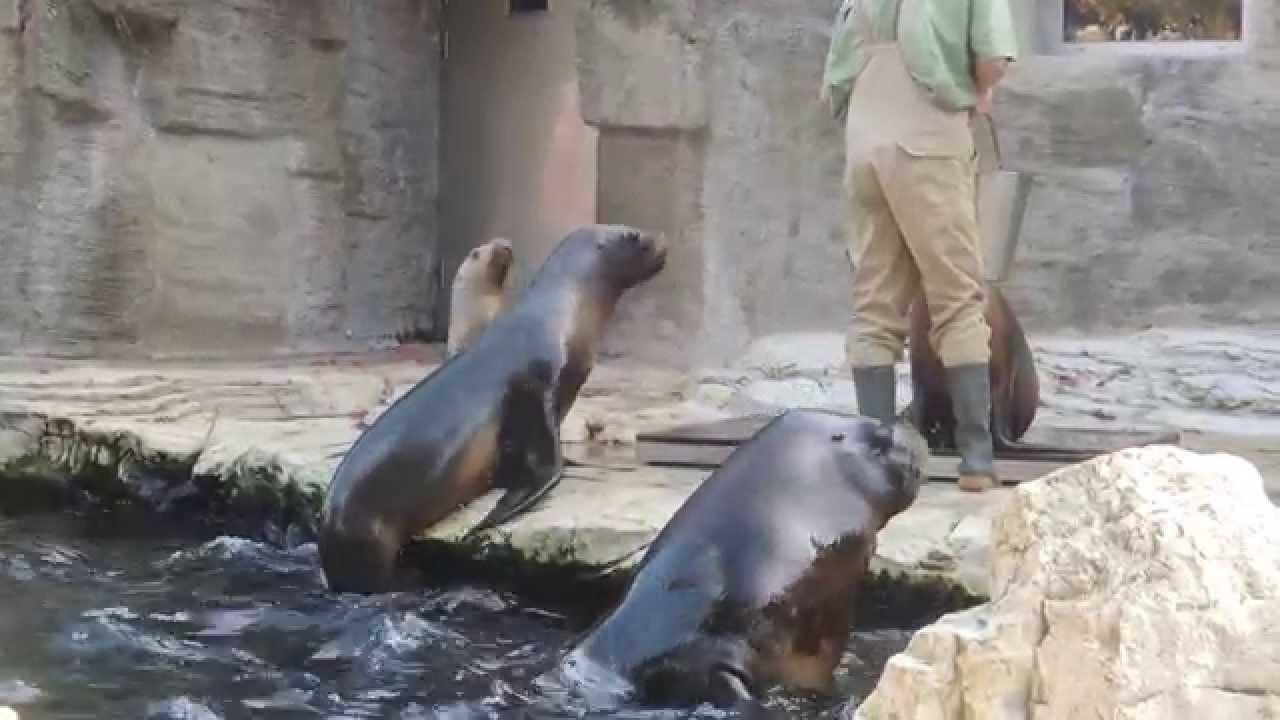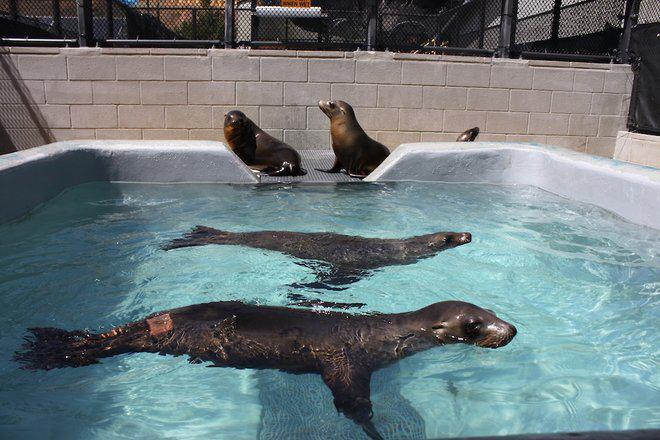The first image is the image on the left, the second image is the image on the right. For the images displayed, is the sentence "seals are swimming in a square pool with a tone wall behind them" factually correct? Answer yes or no. Yes. The first image is the image on the left, the second image is the image on the right. For the images shown, is this caption "In one image, there's an aquarist with at least one sea lion." true? Answer yes or no. Yes. 